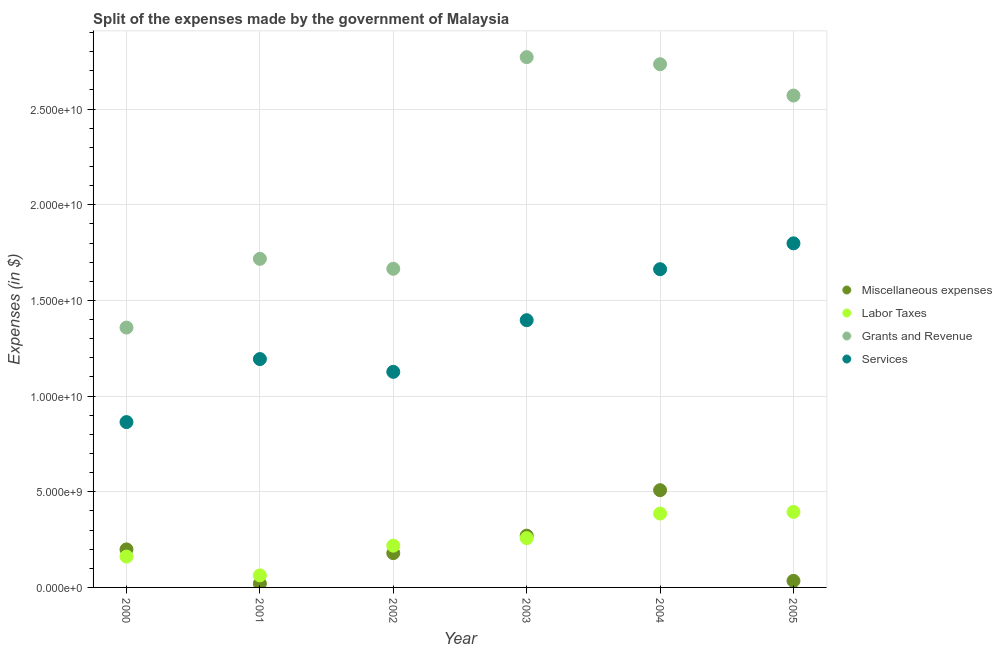Is the number of dotlines equal to the number of legend labels?
Your answer should be compact. Yes. What is the amount spent on miscellaneous expenses in 2001?
Ensure brevity in your answer.  1.99e+08. Across all years, what is the maximum amount spent on grants and revenue?
Give a very brief answer. 2.77e+1. Across all years, what is the minimum amount spent on grants and revenue?
Your answer should be very brief. 1.36e+1. What is the total amount spent on services in the graph?
Give a very brief answer. 8.04e+1. What is the difference between the amount spent on grants and revenue in 2002 and that in 2003?
Your answer should be compact. -1.11e+1. What is the difference between the amount spent on labor taxes in 2001 and the amount spent on services in 2004?
Offer a terse response. -1.60e+1. What is the average amount spent on grants and revenue per year?
Keep it short and to the point. 2.14e+1. In the year 2003, what is the difference between the amount spent on grants and revenue and amount spent on miscellaneous expenses?
Offer a very short reply. 2.50e+1. What is the ratio of the amount spent on services in 2003 to that in 2004?
Your response must be concise. 0.84. Is the amount spent on miscellaneous expenses in 2002 less than that in 2003?
Provide a short and direct response. Yes. Is the difference between the amount spent on miscellaneous expenses in 2000 and 2004 greater than the difference between the amount spent on services in 2000 and 2004?
Offer a terse response. Yes. What is the difference between the highest and the second highest amount spent on grants and revenue?
Ensure brevity in your answer.  3.70e+08. What is the difference between the highest and the lowest amount spent on grants and revenue?
Your answer should be very brief. 1.41e+1. In how many years, is the amount spent on miscellaneous expenses greater than the average amount spent on miscellaneous expenses taken over all years?
Ensure brevity in your answer.  2. Is the sum of the amount spent on miscellaneous expenses in 2000 and 2005 greater than the maximum amount spent on grants and revenue across all years?
Ensure brevity in your answer.  No. Is it the case that in every year, the sum of the amount spent on miscellaneous expenses and amount spent on labor taxes is greater than the amount spent on grants and revenue?
Keep it short and to the point. No. Is the amount spent on miscellaneous expenses strictly less than the amount spent on grants and revenue over the years?
Make the answer very short. Yes. How many years are there in the graph?
Provide a succinct answer. 6. Are the values on the major ticks of Y-axis written in scientific E-notation?
Ensure brevity in your answer.  Yes. Does the graph contain any zero values?
Keep it short and to the point. No. Does the graph contain grids?
Provide a succinct answer. Yes. How many legend labels are there?
Your response must be concise. 4. What is the title of the graph?
Ensure brevity in your answer.  Split of the expenses made by the government of Malaysia. What is the label or title of the Y-axis?
Your response must be concise. Expenses (in $). What is the Expenses (in $) in Miscellaneous expenses in 2000?
Keep it short and to the point. 1.99e+09. What is the Expenses (in $) in Labor Taxes in 2000?
Your answer should be very brief. 1.61e+09. What is the Expenses (in $) in Grants and Revenue in 2000?
Keep it short and to the point. 1.36e+1. What is the Expenses (in $) of Services in 2000?
Your response must be concise. 8.64e+09. What is the Expenses (in $) in Miscellaneous expenses in 2001?
Offer a very short reply. 1.99e+08. What is the Expenses (in $) of Labor Taxes in 2001?
Offer a very short reply. 6.28e+08. What is the Expenses (in $) in Grants and Revenue in 2001?
Offer a very short reply. 1.72e+1. What is the Expenses (in $) of Services in 2001?
Provide a succinct answer. 1.19e+1. What is the Expenses (in $) in Miscellaneous expenses in 2002?
Give a very brief answer. 1.79e+09. What is the Expenses (in $) of Labor Taxes in 2002?
Make the answer very short. 2.18e+09. What is the Expenses (in $) in Grants and Revenue in 2002?
Your response must be concise. 1.67e+1. What is the Expenses (in $) in Services in 2002?
Provide a short and direct response. 1.13e+1. What is the Expenses (in $) in Miscellaneous expenses in 2003?
Provide a short and direct response. 2.71e+09. What is the Expenses (in $) in Labor Taxes in 2003?
Make the answer very short. 2.58e+09. What is the Expenses (in $) in Grants and Revenue in 2003?
Offer a terse response. 2.77e+1. What is the Expenses (in $) of Services in 2003?
Make the answer very short. 1.40e+1. What is the Expenses (in $) of Miscellaneous expenses in 2004?
Offer a very short reply. 5.08e+09. What is the Expenses (in $) in Labor Taxes in 2004?
Provide a short and direct response. 3.86e+09. What is the Expenses (in $) of Grants and Revenue in 2004?
Offer a terse response. 2.73e+1. What is the Expenses (in $) of Services in 2004?
Offer a very short reply. 1.66e+1. What is the Expenses (in $) in Miscellaneous expenses in 2005?
Your answer should be compact. 3.43e+08. What is the Expenses (in $) in Labor Taxes in 2005?
Offer a very short reply. 3.95e+09. What is the Expenses (in $) in Grants and Revenue in 2005?
Provide a short and direct response. 2.57e+1. What is the Expenses (in $) of Services in 2005?
Provide a short and direct response. 1.80e+1. Across all years, what is the maximum Expenses (in $) in Miscellaneous expenses?
Give a very brief answer. 5.08e+09. Across all years, what is the maximum Expenses (in $) in Labor Taxes?
Keep it short and to the point. 3.95e+09. Across all years, what is the maximum Expenses (in $) of Grants and Revenue?
Keep it short and to the point. 2.77e+1. Across all years, what is the maximum Expenses (in $) in Services?
Provide a succinct answer. 1.80e+1. Across all years, what is the minimum Expenses (in $) in Miscellaneous expenses?
Your answer should be compact. 1.99e+08. Across all years, what is the minimum Expenses (in $) of Labor Taxes?
Offer a very short reply. 6.28e+08. Across all years, what is the minimum Expenses (in $) of Grants and Revenue?
Your answer should be compact. 1.36e+1. Across all years, what is the minimum Expenses (in $) in Services?
Offer a very short reply. 8.64e+09. What is the total Expenses (in $) in Miscellaneous expenses in the graph?
Provide a short and direct response. 1.21e+1. What is the total Expenses (in $) of Labor Taxes in the graph?
Give a very brief answer. 1.48e+1. What is the total Expenses (in $) of Grants and Revenue in the graph?
Your answer should be compact. 1.28e+11. What is the total Expenses (in $) in Services in the graph?
Your answer should be compact. 8.04e+1. What is the difference between the Expenses (in $) in Miscellaneous expenses in 2000 and that in 2001?
Provide a short and direct response. 1.79e+09. What is the difference between the Expenses (in $) of Labor Taxes in 2000 and that in 2001?
Offer a very short reply. 9.85e+08. What is the difference between the Expenses (in $) of Grants and Revenue in 2000 and that in 2001?
Offer a terse response. -3.59e+09. What is the difference between the Expenses (in $) of Services in 2000 and that in 2001?
Make the answer very short. -3.29e+09. What is the difference between the Expenses (in $) of Miscellaneous expenses in 2000 and that in 2002?
Give a very brief answer. 1.96e+08. What is the difference between the Expenses (in $) of Labor Taxes in 2000 and that in 2002?
Your response must be concise. -5.70e+08. What is the difference between the Expenses (in $) in Grants and Revenue in 2000 and that in 2002?
Provide a succinct answer. -3.07e+09. What is the difference between the Expenses (in $) in Services in 2000 and that in 2002?
Offer a terse response. -2.63e+09. What is the difference between the Expenses (in $) of Miscellaneous expenses in 2000 and that in 2003?
Provide a succinct answer. -7.18e+08. What is the difference between the Expenses (in $) in Labor Taxes in 2000 and that in 2003?
Offer a very short reply. -9.63e+08. What is the difference between the Expenses (in $) of Grants and Revenue in 2000 and that in 2003?
Keep it short and to the point. -1.41e+1. What is the difference between the Expenses (in $) of Services in 2000 and that in 2003?
Your response must be concise. -5.33e+09. What is the difference between the Expenses (in $) in Miscellaneous expenses in 2000 and that in 2004?
Keep it short and to the point. -3.09e+09. What is the difference between the Expenses (in $) of Labor Taxes in 2000 and that in 2004?
Your response must be concise. -2.25e+09. What is the difference between the Expenses (in $) in Grants and Revenue in 2000 and that in 2004?
Offer a terse response. -1.38e+1. What is the difference between the Expenses (in $) of Services in 2000 and that in 2004?
Ensure brevity in your answer.  -7.99e+09. What is the difference between the Expenses (in $) of Miscellaneous expenses in 2000 and that in 2005?
Your answer should be compact. 1.64e+09. What is the difference between the Expenses (in $) in Labor Taxes in 2000 and that in 2005?
Offer a very short reply. -2.33e+09. What is the difference between the Expenses (in $) in Grants and Revenue in 2000 and that in 2005?
Make the answer very short. -1.21e+1. What is the difference between the Expenses (in $) of Services in 2000 and that in 2005?
Your answer should be very brief. -9.34e+09. What is the difference between the Expenses (in $) in Miscellaneous expenses in 2001 and that in 2002?
Your answer should be compact. -1.59e+09. What is the difference between the Expenses (in $) in Labor Taxes in 2001 and that in 2002?
Keep it short and to the point. -1.55e+09. What is the difference between the Expenses (in $) in Grants and Revenue in 2001 and that in 2002?
Ensure brevity in your answer.  5.19e+08. What is the difference between the Expenses (in $) in Services in 2001 and that in 2002?
Ensure brevity in your answer.  6.67e+08. What is the difference between the Expenses (in $) in Miscellaneous expenses in 2001 and that in 2003?
Offer a very short reply. -2.51e+09. What is the difference between the Expenses (in $) of Labor Taxes in 2001 and that in 2003?
Your answer should be very brief. -1.95e+09. What is the difference between the Expenses (in $) in Grants and Revenue in 2001 and that in 2003?
Make the answer very short. -1.05e+1. What is the difference between the Expenses (in $) in Services in 2001 and that in 2003?
Provide a succinct answer. -2.03e+09. What is the difference between the Expenses (in $) in Miscellaneous expenses in 2001 and that in 2004?
Your answer should be very brief. -4.88e+09. What is the difference between the Expenses (in $) of Labor Taxes in 2001 and that in 2004?
Provide a succinct answer. -3.23e+09. What is the difference between the Expenses (in $) of Grants and Revenue in 2001 and that in 2004?
Offer a very short reply. -1.02e+1. What is the difference between the Expenses (in $) of Services in 2001 and that in 2004?
Ensure brevity in your answer.  -4.70e+09. What is the difference between the Expenses (in $) in Miscellaneous expenses in 2001 and that in 2005?
Provide a short and direct response. -1.44e+08. What is the difference between the Expenses (in $) in Labor Taxes in 2001 and that in 2005?
Your answer should be compact. -3.32e+09. What is the difference between the Expenses (in $) of Grants and Revenue in 2001 and that in 2005?
Your response must be concise. -8.54e+09. What is the difference between the Expenses (in $) in Services in 2001 and that in 2005?
Offer a terse response. -6.05e+09. What is the difference between the Expenses (in $) in Miscellaneous expenses in 2002 and that in 2003?
Your answer should be compact. -9.14e+08. What is the difference between the Expenses (in $) of Labor Taxes in 2002 and that in 2003?
Provide a short and direct response. -3.93e+08. What is the difference between the Expenses (in $) in Grants and Revenue in 2002 and that in 2003?
Offer a terse response. -1.11e+1. What is the difference between the Expenses (in $) in Services in 2002 and that in 2003?
Offer a very short reply. -2.70e+09. What is the difference between the Expenses (in $) of Miscellaneous expenses in 2002 and that in 2004?
Keep it short and to the point. -3.29e+09. What is the difference between the Expenses (in $) in Labor Taxes in 2002 and that in 2004?
Provide a succinct answer. -1.68e+09. What is the difference between the Expenses (in $) in Grants and Revenue in 2002 and that in 2004?
Your response must be concise. -1.07e+1. What is the difference between the Expenses (in $) of Services in 2002 and that in 2004?
Give a very brief answer. -5.36e+09. What is the difference between the Expenses (in $) of Miscellaneous expenses in 2002 and that in 2005?
Provide a succinct answer. 1.45e+09. What is the difference between the Expenses (in $) of Labor Taxes in 2002 and that in 2005?
Offer a very short reply. -1.76e+09. What is the difference between the Expenses (in $) in Grants and Revenue in 2002 and that in 2005?
Your answer should be very brief. -9.06e+09. What is the difference between the Expenses (in $) of Services in 2002 and that in 2005?
Offer a terse response. -6.72e+09. What is the difference between the Expenses (in $) of Miscellaneous expenses in 2003 and that in 2004?
Make the answer very short. -2.38e+09. What is the difference between the Expenses (in $) of Labor Taxes in 2003 and that in 2004?
Offer a very short reply. -1.28e+09. What is the difference between the Expenses (in $) in Grants and Revenue in 2003 and that in 2004?
Your answer should be very brief. 3.70e+08. What is the difference between the Expenses (in $) of Services in 2003 and that in 2004?
Offer a very short reply. -2.66e+09. What is the difference between the Expenses (in $) of Miscellaneous expenses in 2003 and that in 2005?
Provide a succinct answer. 2.36e+09. What is the difference between the Expenses (in $) in Labor Taxes in 2003 and that in 2005?
Keep it short and to the point. -1.37e+09. What is the difference between the Expenses (in $) in Grants and Revenue in 2003 and that in 2005?
Offer a terse response. 2.01e+09. What is the difference between the Expenses (in $) in Services in 2003 and that in 2005?
Make the answer very short. -4.02e+09. What is the difference between the Expenses (in $) of Miscellaneous expenses in 2004 and that in 2005?
Your response must be concise. 4.74e+09. What is the difference between the Expenses (in $) of Labor Taxes in 2004 and that in 2005?
Your answer should be compact. -8.70e+07. What is the difference between the Expenses (in $) in Grants and Revenue in 2004 and that in 2005?
Provide a succinct answer. 1.64e+09. What is the difference between the Expenses (in $) in Services in 2004 and that in 2005?
Your answer should be very brief. -1.35e+09. What is the difference between the Expenses (in $) of Miscellaneous expenses in 2000 and the Expenses (in $) of Labor Taxes in 2001?
Your response must be concise. 1.36e+09. What is the difference between the Expenses (in $) in Miscellaneous expenses in 2000 and the Expenses (in $) in Grants and Revenue in 2001?
Make the answer very short. -1.52e+1. What is the difference between the Expenses (in $) in Miscellaneous expenses in 2000 and the Expenses (in $) in Services in 2001?
Your response must be concise. -9.95e+09. What is the difference between the Expenses (in $) in Labor Taxes in 2000 and the Expenses (in $) in Grants and Revenue in 2001?
Provide a short and direct response. -1.56e+1. What is the difference between the Expenses (in $) of Labor Taxes in 2000 and the Expenses (in $) of Services in 2001?
Your response must be concise. -1.03e+1. What is the difference between the Expenses (in $) of Grants and Revenue in 2000 and the Expenses (in $) of Services in 2001?
Your answer should be compact. 1.65e+09. What is the difference between the Expenses (in $) in Miscellaneous expenses in 2000 and the Expenses (in $) in Labor Taxes in 2002?
Give a very brief answer. -1.95e+08. What is the difference between the Expenses (in $) of Miscellaneous expenses in 2000 and the Expenses (in $) of Grants and Revenue in 2002?
Your response must be concise. -1.47e+1. What is the difference between the Expenses (in $) of Miscellaneous expenses in 2000 and the Expenses (in $) of Services in 2002?
Your answer should be compact. -9.28e+09. What is the difference between the Expenses (in $) of Labor Taxes in 2000 and the Expenses (in $) of Grants and Revenue in 2002?
Provide a short and direct response. -1.50e+1. What is the difference between the Expenses (in $) in Labor Taxes in 2000 and the Expenses (in $) in Services in 2002?
Offer a very short reply. -9.66e+09. What is the difference between the Expenses (in $) of Grants and Revenue in 2000 and the Expenses (in $) of Services in 2002?
Make the answer very short. 2.31e+09. What is the difference between the Expenses (in $) of Miscellaneous expenses in 2000 and the Expenses (in $) of Labor Taxes in 2003?
Your response must be concise. -5.88e+08. What is the difference between the Expenses (in $) in Miscellaneous expenses in 2000 and the Expenses (in $) in Grants and Revenue in 2003?
Offer a terse response. -2.57e+1. What is the difference between the Expenses (in $) of Miscellaneous expenses in 2000 and the Expenses (in $) of Services in 2003?
Offer a terse response. -1.20e+1. What is the difference between the Expenses (in $) of Labor Taxes in 2000 and the Expenses (in $) of Grants and Revenue in 2003?
Your answer should be compact. -2.61e+1. What is the difference between the Expenses (in $) in Labor Taxes in 2000 and the Expenses (in $) in Services in 2003?
Ensure brevity in your answer.  -1.24e+1. What is the difference between the Expenses (in $) in Grants and Revenue in 2000 and the Expenses (in $) in Services in 2003?
Keep it short and to the point. -3.86e+08. What is the difference between the Expenses (in $) in Miscellaneous expenses in 2000 and the Expenses (in $) in Labor Taxes in 2004?
Your response must be concise. -1.87e+09. What is the difference between the Expenses (in $) of Miscellaneous expenses in 2000 and the Expenses (in $) of Grants and Revenue in 2004?
Offer a very short reply. -2.54e+1. What is the difference between the Expenses (in $) of Miscellaneous expenses in 2000 and the Expenses (in $) of Services in 2004?
Give a very brief answer. -1.46e+1. What is the difference between the Expenses (in $) of Labor Taxes in 2000 and the Expenses (in $) of Grants and Revenue in 2004?
Keep it short and to the point. -2.57e+1. What is the difference between the Expenses (in $) of Labor Taxes in 2000 and the Expenses (in $) of Services in 2004?
Your answer should be very brief. -1.50e+1. What is the difference between the Expenses (in $) of Grants and Revenue in 2000 and the Expenses (in $) of Services in 2004?
Keep it short and to the point. -3.05e+09. What is the difference between the Expenses (in $) of Miscellaneous expenses in 2000 and the Expenses (in $) of Labor Taxes in 2005?
Provide a succinct answer. -1.96e+09. What is the difference between the Expenses (in $) in Miscellaneous expenses in 2000 and the Expenses (in $) in Grants and Revenue in 2005?
Offer a very short reply. -2.37e+1. What is the difference between the Expenses (in $) of Miscellaneous expenses in 2000 and the Expenses (in $) of Services in 2005?
Keep it short and to the point. -1.60e+1. What is the difference between the Expenses (in $) of Labor Taxes in 2000 and the Expenses (in $) of Grants and Revenue in 2005?
Offer a terse response. -2.41e+1. What is the difference between the Expenses (in $) of Labor Taxes in 2000 and the Expenses (in $) of Services in 2005?
Offer a terse response. -1.64e+1. What is the difference between the Expenses (in $) in Grants and Revenue in 2000 and the Expenses (in $) in Services in 2005?
Keep it short and to the point. -4.40e+09. What is the difference between the Expenses (in $) of Miscellaneous expenses in 2001 and the Expenses (in $) of Labor Taxes in 2002?
Keep it short and to the point. -1.98e+09. What is the difference between the Expenses (in $) in Miscellaneous expenses in 2001 and the Expenses (in $) in Grants and Revenue in 2002?
Provide a short and direct response. -1.65e+1. What is the difference between the Expenses (in $) of Miscellaneous expenses in 2001 and the Expenses (in $) of Services in 2002?
Your answer should be compact. -1.11e+1. What is the difference between the Expenses (in $) in Labor Taxes in 2001 and the Expenses (in $) in Grants and Revenue in 2002?
Provide a succinct answer. -1.60e+1. What is the difference between the Expenses (in $) of Labor Taxes in 2001 and the Expenses (in $) of Services in 2002?
Ensure brevity in your answer.  -1.06e+1. What is the difference between the Expenses (in $) of Grants and Revenue in 2001 and the Expenses (in $) of Services in 2002?
Ensure brevity in your answer.  5.91e+09. What is the difference between the Expenses (in $) of Miscellaneous expenses in 2001 and the Expenses (in $) of Labor Taxes in 2003?
Keep it short and to the point. -2.38e+09. What is the difference between the Expenses (in $) of Miscellaneous expenses in 2001 and the Expenses (in $) of Grants and Revenue in 2003?
Your response must be concise. -2.75e+1. What is the difference between the Expenses (in $) in Miscellaneous expenses in 2001 and the Expenses (in $) in Services in 2003?
Provide a succinct answer. -1.38e+1. What is the difference between the Expenses (in $) of Labor Taxes in 2001 and the Expenses (in $) of Grants and Revenue in 2003?
Make the answer very short. -2.71e+1. What is the difference between the Expenses (in $) of Labor Taxes in 2001 and the Expenses (in $) of Services in 2003?
Provide a succinct answer. -1.33e+1. What is the difference between the Expenses (in $) in Grants and Revenue in 2001 and the Expenses (in $) in Services in 2003?
Provide a short and direct response. 3.21e+09. What is the difference between the Expenses (in $) of Miscellaneous expenses in 2001 and the Expenses (in $) of Labor Taxes in 2004?
Make the answer very short. -3.66e+09. What is the difference between the Expenses (in $) in Miscellaneous expenses in 2001 and the Expenses (in $) in Grants and Revenue in 2004?
Keep it short and to the point. -2.71e+1. What is the difference between the Expenses (in $) in Miscellaneous expenses in 2001 and the Expenses (in $) in Services in 2004?
Ensure brevity in your answer.  -1.64e+1. What is the difference between the Expenses (in $) of Labor Taxes in 2001 and the Expenses (in $) of Grants and Revenue in 2004?
Provide a succinct answer. -2.67e+1. What is the difference between the Expenses (in $) in Labor Taxes in 2001 and the Expenses (in $) in Services in 2004?
Ensure brevity in your answer.  -1.60e+1. What is the difference between the Expenses (in $) in Grants and Revenue in 2001 and the Expenses (in $) in Services in 2004?
Give a very brief answer. 5.41e+08. What is the difference between the Expenses (in $) in Miscellaneous expenses in 2001 and the Expenses (in $) in Labor Taxes in 2005?
Provide a succinct answer. -3.75e+09. What is the difference between the Expenses (in $) in Miscellaneous expenses in 2001 and the Expenses (in $) in Grants and Revenue in 2005?
Make the answer very short. -2.55e+1. What is the difference between the Expenses (in $) of Miscellaneous expenses in 2001 and the Expenses (in $) of Services in 2005?
Offer a very short reply. -1.78e+1. What is the difference between the Expenses (in $) in Labor Taxes in 2001 and the Expenses (in $) in Grants and Revenue in 2005?
Your answer should be compact. -2.51e+1. What is the difference between the Expenses (in $) of Labor Taxes in 2001 and the Expenses (in $) of Services in 2005?
Your answer should be compact. -1.74e+1. What is the difference between the Expenses (in $) of Grants and Revenue in 2001 and the Expenses (in $) of Services in 2005?
Your answer should be compact. -8.10e+08. What is the difference between the Expenses (in $) in Miscellaneous expenses in 2002 and the Expenses (in $) in Labor Taxes in 2003?
Your answer should be compact. -7.84e+08. What is the difference between the Expenses (in $) of Miscellaneous expenses in 2002 and the Expenses (in $) of Grants and Revenue in 2003?
Your answer should be very brief. -2.59e+1. What is the difference between the Expenses (in $) of Miscellaneous expenses in 2002 and the Expenses (in $) of Services in 2003?
Provide a short and direct response. -1.22e+1. What is the difference between the Expenses (in $) of Labor Taxes in 2002 and the Expenses (in $) of Grants and Revenue in 2003?
Ensure brevity in your answer.  -2.55e+1. What is the difference between the Expenses (in $) in Labor Taxes in 2002 and the Expenses (in $) in Services in 2003?
Offer a terse response. -1.18e+1. What is the difference between the Expenses (in $) of Grants and Revenue in 2002 and the Expenses (in $) of Services in 2003?
Provide a short and direct response. 2.69e+09. What is the difference between the Expenses (in $) in Miscellaneous expenses in 2002 and the Expenses (in $) in Labor Taxes in 2004?
Provide a short and direct response. -2.07e+09. What is the difference between the Expenses (in $) in Miscellaneous expenses in 2002 and the Expenses (in $) in Grants and Revenue in 2004?
Make the answer very short. -2.56e+1. What is the difference between the Expenses (in $) of Miscellaneous expenses in 2002 and the Expenses (in $) of Services in 2004?
Offer a terse response. -1.48e+1. What is the difference between the Expenses (in $) of Labor Taxes in 2002 and the Expenses (in $) of Grants and Revenue in 2004?
Offer a very short reply. -2.52e+1. What is the difference between the Expenses (in $) of Labor Taxes in 2002 and the Expenses (in $) of Services in 2004?
Make the answer very short. -1.44e+1. What is the difference between the Expenses (in $) in Grants and Revenue in 2002 and the Expenses (in $) in Services in 2004?
Keep it short and to the point. 2.20e+07. What is the difference between the Expenses (in $) in Miscellaneous expenses in 2002 and the Expenses (in $) in Labor Taxes in 2005?
Make the answer very short. -2.16e+09. What is the difference between the Expenses (in $) of Miscellaneous expenses in 2002 and the Expenses (in $) of Grants and Revenue in 2005?
Provide a succinct answer. -2.39e+1. What is the difference between the Expenses (in $) of Miscellaneous expenses in 2002 and the Expenses (in $) of Services in 2005?
Keep it short and to the point. -1.62e+1. What is the difference between the Expenses (in $) of Labor Taxes in 2002 and the Expenses (in $) of Grants and Revenue in 2005?
Make the answer very short. -2.35e+1. What is the difference between the Expenses (in $) of Labor Taxes in 2002 and the Expenses (in $) of Services in 2005?
Provide a succinct answer. -1.58e+1. What is the difference between the Expenses (in $) of Grants and Revenue in 2002 and the Expenses (in $) of Services in 2005?
Your answer should be compact. -1.33e+09. What is the difference between the Expenses (in $) of Miscellaneous expenses in 2003 and the Expenses (in $) of Labor Taxes in 2004?
Keep it short and to the point. -1.15e+09. What is the difference between the Expenses (in $) of Miscellaneous expenses in 2003 and the Expenses (in $) of Grants and Revenue in 2004?
Offer a very short reply. -2.46e+1. What is the difference between the Expenses (in $) in Miscellaneous expenses in 2003 and the Expenses (in $) in Services in 2004?
Your answer should be very brief. -1.39e+1. What is the difference between the Expenses (in $) in Labor Taxes in 2003 and the Expenses (in $) in Grants and Revenue in 2004?
Offer a terse response. -2.48e+1. What is the difference between the Expenses (in $) in Labor Taxes in 2003 and the Expenses (in $) in Services in 2004?
Offer a very short reply. -1.41e+1. What is the difference between the Expenses (in $) in Grants and Revenue in 2003 and the Expenses (in $) in Services in 2004?
Your answer should be very brief. 1.11e+1. What is the difference between the Expenses (in $) of Miscellaneous expenses in 2003 and the Expenses (in $) of Labor Taxes in 2005?
Ensure brevity in your answer.  -1.24e+09. What is the difference between the Expenses (in $) in Miscellaneous expenses in 2003 and the Expenses (in $) in Grants and Revenue in 2005?
Offer a terse response. -2.30e+1. What is the difference between the Expenses (in $) in Miscellaneous expenses in 2003 and the Expenses (in $) in Services in 2005?
Offer a very short reply. -1.53e+1. What is the difference between the Expenses (in $) in Labor Taxes in 2003 and the Expenses (in $) in Grants and Revenue in 2005?
Provide a succinct answer. -2.31e+1. What is the difference between the Expenses (in $) of Labor Taxes in 2003 and the Expenses (in $) of Services in 2005?
Give a very brief answer. -1.54e+1. What is the difference between the Expenses (in $) in Grants and Revenue in 2003 and the Expenses (in $) in Services in 2005?
Your answer should be compact. 9.73e+09. What is the difference between the Expenses (in $) of Miscellaneous expenses in 2004 and the Expenses (in $) of Labor Taxes in 2005?
Provide a short and direct response. 1.14e+09. What is the difference between the Expenses (in $) of Miscellaneous expenses in 2004 and the Expenses (in $) of Grants and Revenue in 2005?
Your response must be concise. -2.06e+1. What is the difference between the Expenses (in $) in Miscellaneous expenses in 2004 and the Expenses (in $) in Services in 2005?
Your response must be concise. -1.29e+1. What is the difference between the Expenses (in $) in Labor Taxes in 2004 and the Expenses (in $) in Grants and Revenue in 2005?
Keep it short and to the point. -2.18e+1. What is the difference between the Expenses (in $) of Labor Taxes in 2004 and the Expenses (in $) of Services in 2005?
Provide a succinct answer. -1.41e+1. What is the difference between the Expenses (in $) of Grants and Revenue in 2004 and the Expenses (in $) of Services in 2005?
Offer a terse response. 9.36e+09. What is the average Expenses (in $) in Miscellaneous expenses per year?
Provide a short and direct response. 2.02e+09. What is the average Expenses (in $) of Labor Taxes per year?
Your answer should be very brief. 2.47e+09. What is the average Expenses (in $) in Grants and Revenue per year?
Your response must be concise. 2.14e+1. What is the average Expenses (in $) of Services per year?
Your answer should be very brief. 1.34e+1. In the year 2000, what is the difference between the Expenses (in $) of Miscellaneous expenses and Expenses (in $) of Labor Taxes?
Offer a very short reply. 3.75e+08. In the year 2000, what is the difference between the Expenses (in $) of Miscellaneous expenses and Expenses (in $) of Grants and Revenue?
Give a very brief answer. -1.16e+1. In the year 2000, what is the difference between the Expenses (in $) in Miscellaneous expenses and Expenses (in $) in Services?
Your answer should be very brief. -6.65e+09. In the year 2000, what is the difference between the Expenses (in $) in Labor Taxes and Expenses (in $) in Grants and Revenue?
Your response must be concise. -1.20e+1. In the year 2000, what is the difference between the Expenses (in $) in Labor Taxes and Expenses (in $) in Services?
Give a very brief answer. -7.03e+09. In the year 2000, what is the difference between the Expenses (in $) of Grants and Revenue and Expenses (in $) of Services?
Provide a short and direct response. 4.94e+09. In the year 2001, what is the difference between the Expenses (in $) of Miscellaneous expenses and Expenses (in $) of Labor Taxes?
Provide a succinct answer. -4.30e+08. In the year 2001, what is the difference between the Expenses (in $) in Miscellaneous expenses and Expenses (in $) in Grants and Revenue?
Ensure brevity in your answer.  -1.70e+1. In the year 2001, what is the difference between the Expenses (in $) of Miscellaneous expenses and Expenses (in $) of Services?
Offer a terse response. -1.17e+1. In the year 2001, what is the difference between the Expenses (in $) of Labor Taxes and Expenses (in $) of Grants and Revenue?
Your answer should be compact. -1.65e+1. In the year 2001, what is the difference between the Expenses (in $) of Labor Taxes and Expenses (in $) of Services?
Provide a succinct answer. -1.13e+1. In the year 2001, what is the difference between the Expenses (in $) in Grants and Revenue and Expenses (in $) in Services?
Offer a very short reply. 5.24e+09. In the year 2002, what is the difference between the Expenses (in $) of Miscellaneous expenses and Expenses (in $) of Labor Taxes?
Your answer should be very brief. -3.91e+08. In the year 2002, what is the difference between the Expenses (in $) in Miscellaneous expenses and Expenses (in $) in Grants and Revenue?
Your answer should be very brief. -1.49e+1. In the year 2002, what is the difference between the Expenses (in $) in Miscellaneous expenses and Expenses (in $) in Services?
Ensure brevity in your answer.  -9.48e+09. In the year 2002, what is the difference between the Expenses (in $) of Labor Taxes and Expenses (in $) of Grants and Revenue?
Offer a terse response. -1.45e+1. In the year 2002, what is the difference between the Expenses (in $) of Labor Taxes and Expenses (in $) of Services?
Your answer should be compact. -9.09e+09. In the year 2002, what is the difference between the Expenses (in $) of Grants and Revenue and Expenses (in $) of Services?
Keep it short and to the point. 5.39e+09. In the year 2003, what is the difference between the Expenses (in $) in Miscellaneous expenses and Expenses (in $) in Labor Taxes?
Provide a short and direct response. 1.30e+08. In the year 2003, what is the difference between the Expenses (in $) of Miscellaneous expenses and Expenses (in $) of Grants and Revenue?
Ensure brevity in your answer.  -2.50e+1. In the year 2003, what is the difference between the Expenses (in $) of Miscellaneous expenses and Expenses (in $) of Services?
Your response must be concise. -1.13e+1. In the year 2003, what is the difference between the Expenses (in $) of Labor Taxes and Expenses (in $) of Grants and Revenue?
Ensure brevity in your answer.  -2.51e+1. In the year 2003, what is the difference between the Expenses (in $) of Labor Taxes and Expenses (in $) of Services?
Give a very brief answer. -1.14e+1. In the year 2003, what is the difference between the Expenses (in $) in Grants and Revenue and Expenses (in $) in Services?
Your answer should be compact. 1.37e+1. In the year 2004, what is the difference between the Expenses (in $) of Miscellaneous expenses and Expenses (in $) of Labor Taxes?
Make the answer very short. 1.22e+09. In the year 2004, what is the difference between the Expenses (in $) of Miscellaneous expenses and Expenses (in $) of Grants and Revenue?
Your answer should be very brief. -2.23e+1. In the year 2004, what is the difference between the Expenses (in $) in Miscellaneous expenses and Expenses (in $) in Services?
Provide a succinct answer. -1.16e+1. In the year 2004, what is the difference between the Expenses (in $) of Labor Taxes and Expenses (in $) of Grants and Revenue?
Your answer should be very brief. -2.35e+1. In the year 2004, what is the difference between the Expenses (in $) in Labor Taxes and Expenses (in $) in Services?
Give a very brief answer. -1.28e+1. In the year 2004, what is the difference between the Expenses (in $) of Grants and Revenue and Expenses (in $) of Services?
Keep it short and to the point. 1.07e+1. In the year 2005, what is the difference between the Expenses (in $) in Miscellaneous expenses and Expenses (in $) in Labor Taxes?
Offer a very short reply. -3.60e+09. In the year 2005, what is the difference between the Expenses (in $) in Miscellaneous expenses and Expenses (in $) in Grants and Revenue?
Provide a succinct answer. -2.54e+1. In the year 2005, what is the difference between the Expenses (in $) in Miscellaneous expenses and Expenses (in $) in Services?
Ensure brevity in your answer.  -1.76e+1. In the year 2005, what is the difference between the Expenses (in $) of Labor Taxes and Expenses (in $) of Grants and Revenue?
Keep it short and to the point. -2.18e+1. In the year 2005, what is the difference between the Expenses (in $) in Labor Taxes and Expenses (in $) in Services?
Your answer should be very brief. -1.40e+1. In the year 2005, what is the difference between the Expenses (in $) in Grants and Revenue and Expenses (in $) in Services?
Provide a succinct answer. 7.73e+09. What is the ratio of the Expenses (in $) in Miscellaneous expenses in 2000 to that in 2001?
Keep it short and to the point. 9.99. What is the ratio of the Expenses (in $) of Labor Taxes in 2000 to that in 2001?
Offer a terse response. 2.57. What is the ratio of the Expenses (in $) of Grants and Revenue in 2000 to that in 2001?
Make the answer very short. 0.79. What is the ratio of the Expenses (in $) of Services in 2000 to that in 2001?
Your response must be concise. 0.72. What is the ratio of the Expenses (in $) of Miscellaneous expenses in 2000 to that in 2002?
Offer a very short reply. 1.11. What is the ratio of the Expenses (in $) of Labor Taxes in 2000 to that in 2002?
Offer a terse response. 0.74. What is the ratio of the Expenses (in $) in Grants and Revenue in 2000 to that in 2002?
Give a very brief answer. 0.82. What is the ratio of the Expenses (in $) in Services in 2000 to that in 2002?
Your answer should be compact. 0.77. What is the ratio of the Expenses (in $) of Miscellaneous expenses in 2000 to that in 2003?
Make the answer very short. 0.73. What is the ratio of the Expenses (in $) in Labor Taxes in 2000 to that in 2003?
Make the answer very short. 0.63. What is the ratio of the Expenses (in $) of Grants and Revenue in 2000 to that in 2003?
Provide a succinct answer. 0.49. What is the ratio of the Expenses (in $) of Services in 2000 to that in 2003?
Keep it short and to the point. 0.62. What is the ratio of the Expenses (in $) of Miscellaneous expenses in 2000 to that in 2004?
Your answer should be compact. 0.39. What is the ratio of the Expenses (in $) of Labor Taxes in 2000 to that in 2004?
Your answer should be compact. 0.42. What is the ratio of the Expenses (in $) of Grants and Revenue in 2000 to that in 2004?
Provide a short and direct response. 0.5. What is the ratio of the Expenses (in $) of Services in 2000 to that in 2004?
Offer a very short reply. 0.52. What is the ratio of the Expenses (in $) in Miscellaneous expenses in 2000 to that in 2005?
Your answer should be very brief. 5.8. What is the ratio of the Expenses (in $) of Labor Taxes in 2000 to that in 2005?
Offer a terse response. 0.41. What is the ratio of the Expenses (in $) of Grants and Revenue in 2000 to that in 2005?
Offer a terse response. 0.53. What is the ratio of the Expenses (in $) in Services in 2000 to that in 2005?
Make the answer very short. 0.48. What is the ratio of the Expenses (in $) in Miscellaneous expenses in 2001 to that in 2002?
Your response must be concise. 0.11. What is the ratio of the Expenses (in $) in Labor Taxes in 2001 to that in 2002?
Your answer should be very brief. 0.29. What is the ratio of the Expenses (in $) in Grants and Revenue in 2001 to that in 2002?
Make the answer very short. 1.03. What is the ratio of the Expenses (in $) in Services in 2001 to that in 2002?
Provide a succinct answer. 1.06. What is the ratio of the Expenses (in $) in Miscellaneous expenses in 2001 to that in 2003?
Ensure brevity in your answer.  0.07. What is the ratio of the Expenses (in $) of Labor Taxes in 2001 to that in 2003?
Your answer should be compact. 0.24. What is the ratio of the Expenses (in $) of Grants and Revenue in 2001 to that in 2003?
Provide a short and direct response. 0.62. What is the ratio of the Expenses (in $) of Services in 2001 to that in 2003?
Offer a very short reply. 0.85. What is the ratio of the Expenses (in $) in Miscellaneous expenses in 2001 to that in 2004?
Offer a very short reply. 0.04. What is the ratio of the Expenses (in $) in Labor Taxes in 2001 to that in 2004?
Give a very brief answer. 0.16. What is the ratio of the Expenses (in $) in Grants and Revenue in 2001 to that in 2004?
Ensure brevity in your answer.  0.63. What is the ratio of the Expenses (in $) in Services in 2001 to that in 2004?
Give a very brief answer. 0.72. What is the ratio of the Expenses (in $) in Miscellaneous expenses in 2001 to that in 2005?
Your response must be concise. 0.58. What is the ratio of the Expenses (in $) in Labor Taxes in 2001 to that in 2005?
Your answer should be compact. 0.16. What is the ratio of the Expenses (in $) in Grants and Revenue in 2001 to that in 2005?
Provide a succinct answer. 0.67. What is the ratio of the Expenses (in $) of Services in 2001 to that in 2005?
Your answer should be compact. 0.66. What is the ratio of the Expenses (in $) of Miscellaneous expenses in 2002 to that in 2003?
Make the answer very short. 0.66. What is the ratio of the Expenses (in $) of Labor Taxes in 2002 to that in 2003?
Your response must be concise. 0.85. What is the ratio of the Expenses (in $) of Grants and Revenue in 2002 to that in 2003?
Offer a very short reply. 0.6. What is the ratio of the Expenses (in $) of Services in 2002 to that in 2003?
Your answer should be very brief. 0.81. What is the ratio of the Expenses (in $) in Miscellaneous expenses in 2002 to that in 2004?
Make the answer very short. 0.35. What is the ratio of the Expenses (in $) in Labor Taxes in 2002 to that in 2004?
Keep it short and to the point. 0.57. What is the ratio of the Expenses (in $) of Grants and Revenue in 2002 to that in 2004?
Your answer should be compact. 0.61. What is the ratio of the Expenses (in $) in Services in 2002 to that in 2004?
Make the answer very short. 0.68. What is the ratio of the Expenses (in $) in Miscellaneous expenses in 2002 to that in 2005?
Provide a short and direct response. 5.22. What is the ratio of the Expenses (in $) of Labor Taxes in 2002 to that in 2005?
Offer a terse response. 0.55. What is the ratio of the Expenses (in $) of Grants and Revenue in 2002 to that in 2005?
Keep it short and to the point. 0.65. What is the ratio of the Expenses (in $) in Services in 2002 to that in 2005?
Keep it short and to the point. 0.63. What is the ratio of the Expenses (in $) in Miscellaneous expenses in 2003 to that in 2004?
Keep it short and to the point. 0.53. What is the ratio of the Expenses (in $) of Labor Taxes in 2003 to that in 2004?
Your answer should be very brief. 0.67. What is the ratio of the Expenses (in $) of Grants and Revenue in 2003 to that in 2004?
Your answer should be compact. 1.01. What is the ratio of the Expenses (in $) of Services in 2003 to that in 2004?
Make the answer very short. 0.84. What is the ratio of the Expenses (in $) of Miscellaneous expenses in 2003 to that in 2005?
Keep it short and to the point. 7.89. What is the ratio of the Expenses (in $) of Labor Taxes in 2003 to that in 2005?
Keep it short and to the point. 0.65. What is the ratio of the Expenses (in $) of Grants and Revenue in 2003 to that in 2005?
Provide a short and direct response. 1.08. What is the ratio of the Expenses (in $) of Services in 2003 to that in 2005?
Provide a succinct answer. 0.78. What is the ratio of the Expenses (in $) of Miscellaneous expenses in 2004 to that in 2005?
Ensure brevity in your answer.  14.82. What is the ratio of the Expenses (in $) of Grants and Revenue in 2004 to that in 2005?
Your answer should be very brief. 1.06. What is the ratio of the Expenses (in $) of Services in 2004 to that in 2005?
Provide a succinct answer. 0.92. What is the difference between the highest and the second highest Expenses (in $) in Miscellaneous expenses?
Provide a succinct answer. 2.38e+09. What is the difference between the highest and the second highest Expenses (in $) in Labor Taxes?
Offer a terse response. 8.70e+07. What is the difference between the highest and the second highest Expenses (in $) in Grants and Revenue?
Give a very brief answer. 3.70e+08. What is the difference between the highest and the second highest Expenses (in $) in Services?
Give a very brief answer. 1.35e+09. What is the difference between the highest and the lowest Expenses (in $) of Miscellaneous expenses?
Your response must be concise. 4.88e+09. What is the difference between the highest and the lowest Expenses (in $) of Labor Taxes?
Offer a very short reply. 3.32e+09. What is the difference between the highest and the lowest Expenses (in $) of Grants and Revenue?
Your response must be concise. 1.41e+1. What is the difference between the highest and the lowest Expenses (in $) in Services?
Provide a short and direct response. 9.34e+09. 